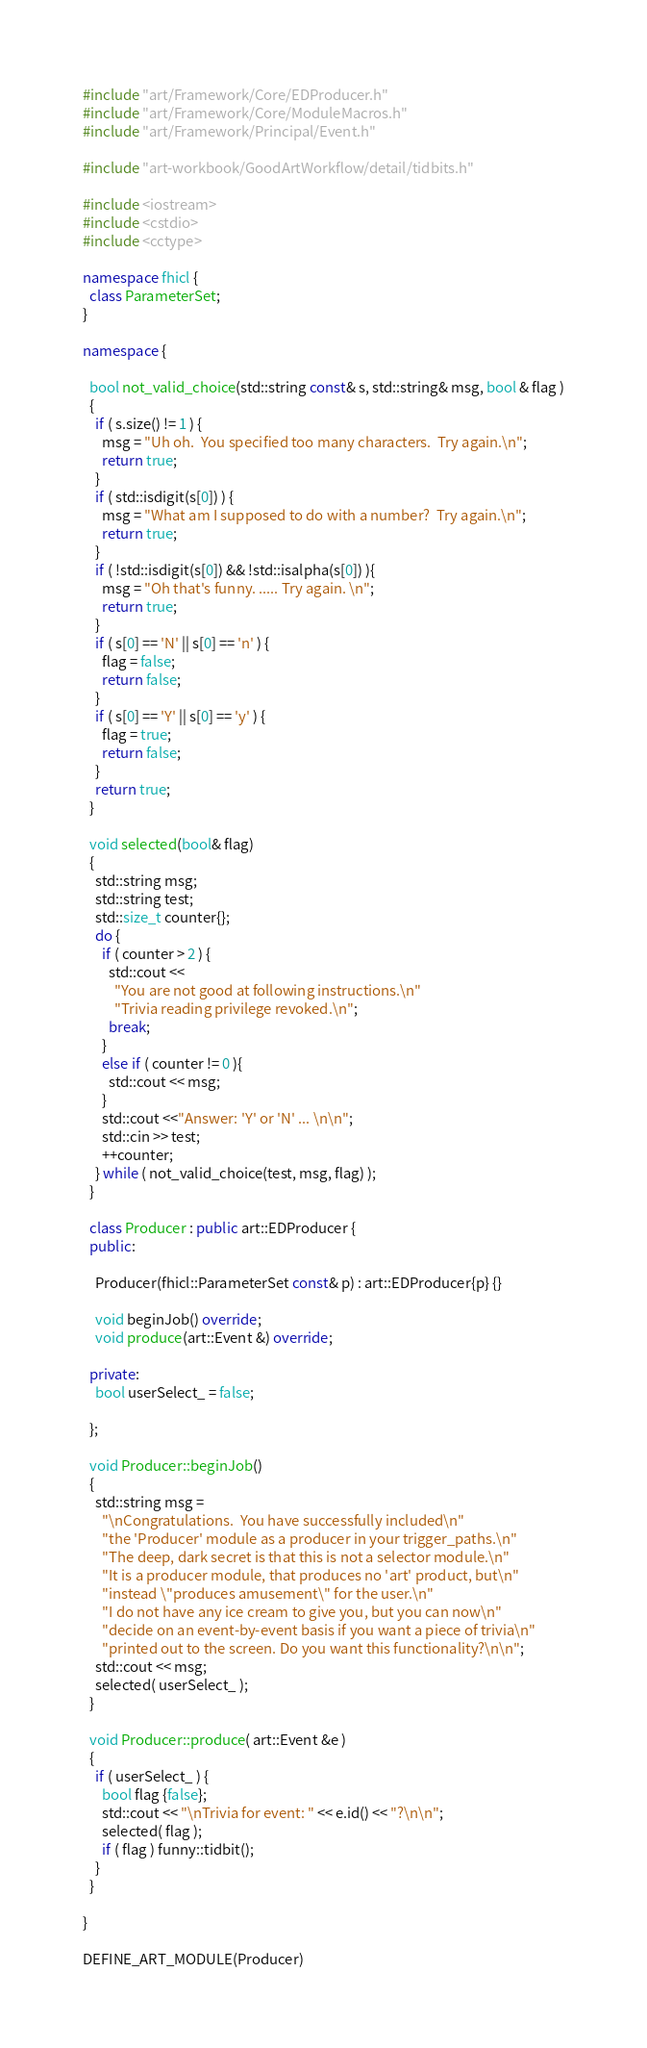<code> <loc_0><loc_0><loc_500><loc_500><_C++_>#include "art/Framework/Core/EDProducer.h"
#include "art/Framework/Core/ModuleMacros.h"
#include "art/Framework/Principal/Event.h"

#include "art-workbook/GoodArtWorkflow/detail/tidbits.h"

#include <iostream>
#include <cstdio>
#include <cctype>

namespace fhicl {
  class ParameterSet;
}

namespace {

  bool not_valid_choice(std::string const& s, std::string& msg, bool & flag )
  {
    if ( s.size() != 1 ) {
      msg = "Uh oh.  You specified too many characters.  Try again.\n";
      return true;
    }
    if ( std::isdigit(s[0]) ) {
      msg = "What am I supposed to do with a number?  Try again.\n";
      return true;
    }
    if ( !std::isdigit(s[0]) && !std::isalpha(s[0]) ){
      msg = "Oh that's funny. ..... Try again. \n";
      return true;
    }
    if ( s[0] == 'N' || s[0] == 'n' ) {
      flag = false;
      return false;
    }
    if ( s[0] == 'Y' || s[0] == 'y' ) {
      flag = true;
      return false;
    }
    return true;
  }

  void selected(bool& flag)
  {
    std::string msg;
    std::string test;
    std::size_t counter{};
    do {
      if ( counter > 2 ) {
        std::cout <<
          "You are not good at following instructions.\n"
          "Trivia reading privilege revoked.\n";
        break;
      }
      else if ( counter != 0 ){
        std::cout << msg;
      }
      std::cout <<"Answer: 'Y' or 'N' ... \n\n";
      std::cin >> test;
      ++counter;
    } while ( not_valid_choice(test, msg, flag) );
  }

  class Producer : public art::EDProducer {
  public:

    Producer(fhicl::ParameterSet const& p) : art::EDProducer{p} {}

    void beginJob() override;
    void produce(art::Event &) override;

  private:
    bool userSelect_ = false;

  };

  void Producer::beginJob()
  {
    std::string msg =
      "\nCongratulations.  You have successfully included\n"
      "the 'Producer' module as a producer in your trigger_paths.\n"
      "The deep, dark secret is that this is not a selector module.\n"
      "It is a producer module, that produces no 'art' product, but\n"
      "instead \"produces amusement\" for the user.\n"
      "I do not have any ice cream to give you, but you can now\n"
      "decide on an event-by-event basis if you want a piece of trivia\n"
      "printed out to the screen. Do you want this functionality?\n\n";
    std::cout << msg;
    selected( userSelect_ );
  }

  void Producer::produce( art::Event &e )
  {
    if ( userSelect_ ) {
      bool flag {false};
      std::cout << "\nTrivia for event: " << e.id() << "?\n\n";
      selected( flag );
      if ( flag ) funny::tidbit();
    }
  }

}

DEFINE_ART_MODULE(Producer)
</code> 